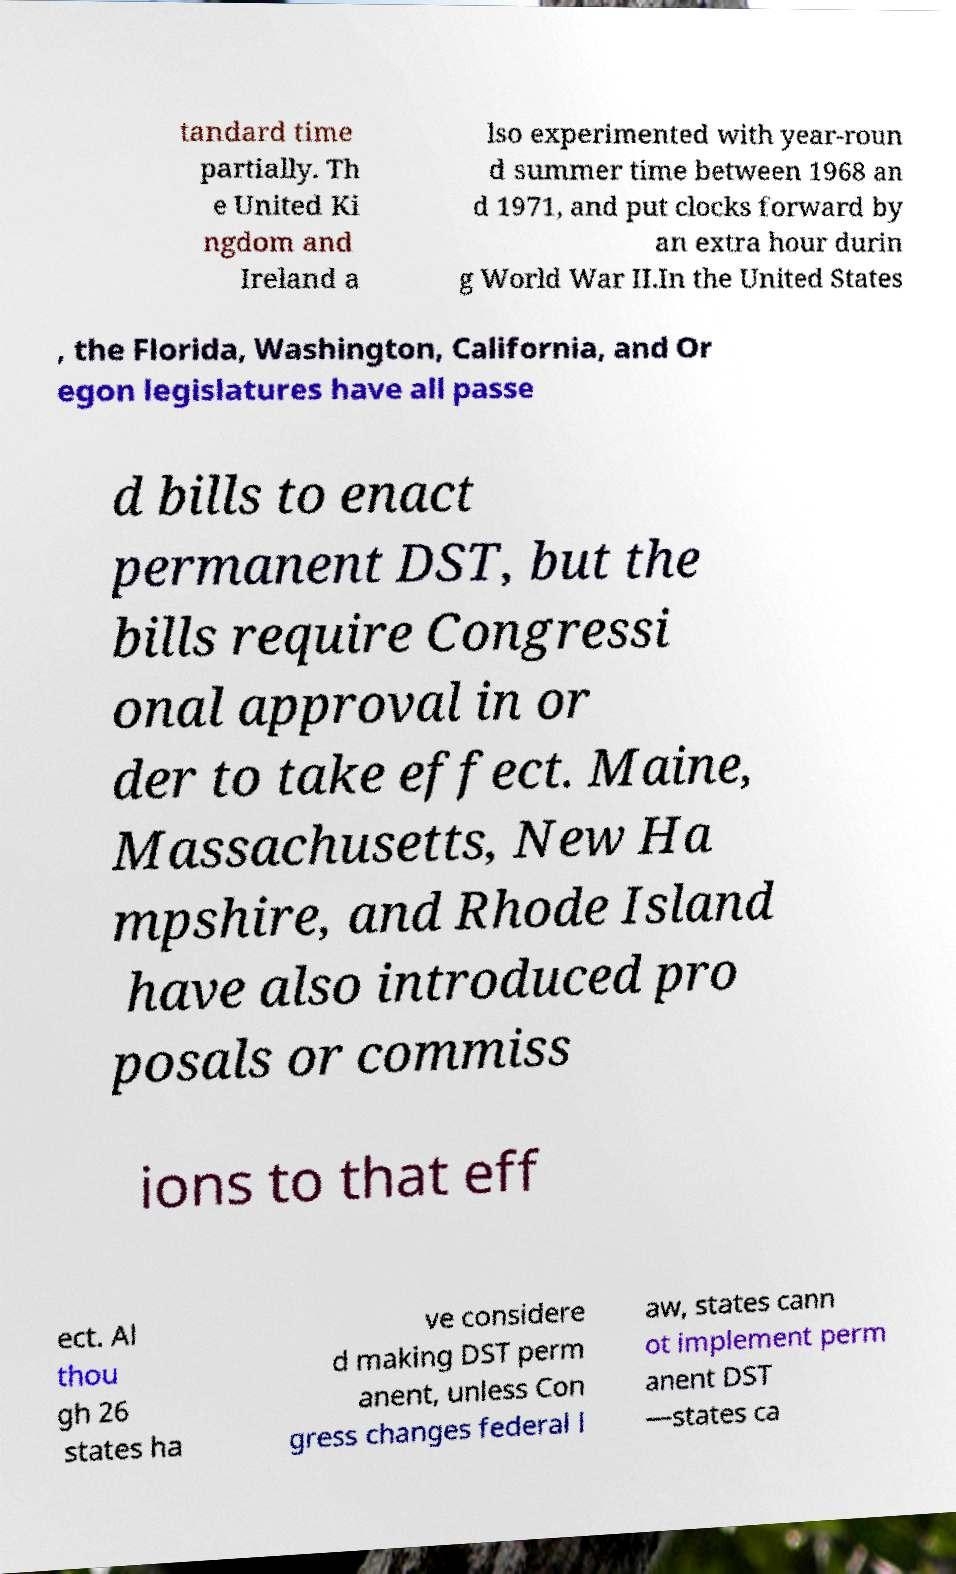Could you extract and type out the text from this image? tandard time partially. Th e United Ki ngdom and Ireland a lso experimented with year-roun d summer time between 1968 an d 1971, and put clocks forward by an extra hour durin g World War II.In the United States , the Florida, Washington, California, and Or egon legislatures have all passe d bills to enact permanent DST, but the bills require Congressi onal approval in or der to take effect. Maine, Massachusetts, New Ha mpshire, and Rhode Island have also introduced pro posals or commiss ions to that eff ect. Al thou gh 26 states ha ve considere d making DST perm anent, unless Con gress changes federal l aw, states cann ot implement perm anent DST —states ca 